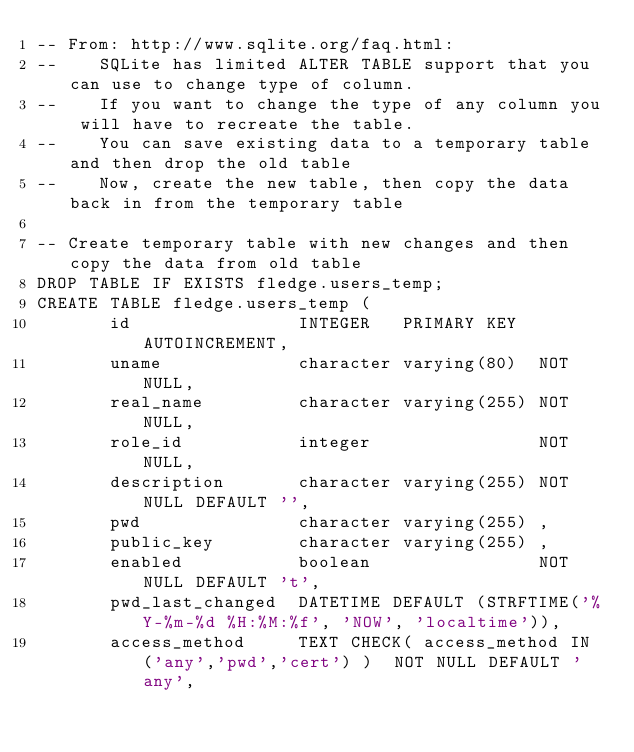Convert code to text. <code><loc_0><loc_0><loc_500><loc_500><_SQL_>-- From: http://www.sqlite.org/faq.html:
--    SQLite has limited ALTER TABLE support that you can use to change type of column.
--    If you want to change the type of any column you will have to recreate the table.
--    You can save existing data to a temporary table and then drop the old table
--    Now, create the new table, then copy the data back in from the temporary table

-- Create temporary table with new changes and then copy the data from old table
DROP TABLE IF EXISTS fledge.users_temp;
CREATE TABLE fledge.users_temp (
       id                INTEGER   PRIMARY KEY AUTOINCREMENT,
       uname             character varying(80)  NOT NULL,
       real_name         character varying(255) NOT NULL,
       role_id           integer                NOT NULL,
       description       character varying(255) NOT NULL DEFAULT '',
       pwd               character varying(255) ,
       public_key        character varying(255) ,
       enabled           boolean                NOT NULL DEFAULT 't',
       pwd_last_changed  DATETIME DEFAULT (STRFTIME('%Y-%m-%d %H:%M:%f', 'NOW', 'localtime')),
       access_method     TEXT CHECK( access_method IN ('any','pwd','cert') )  NOT NULL DEFAULT 'any',</code> 